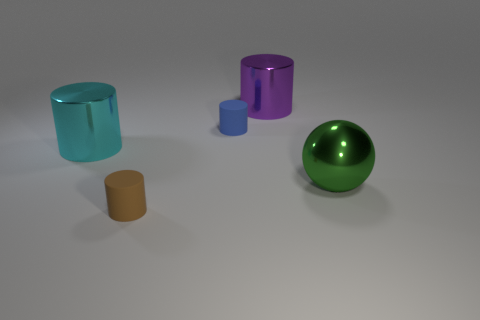Add 5 big metallic cylinders. How many objects exist? 10 Subtract all gray cylinders. Subtract all green cubes. How many cylinders are left? 4 Subtract all spheres. How many objects are left? 4 Add 5 green shiny spheres. How many green shiny spheres exist? 6 Subtract 0 yellow blocks. How many objects are left? 5 Subtract all small red rubber balls. Subtract all big purple shiny things. How many objects are left? 4 Add 3 big balls. How many big balls are left? 4 